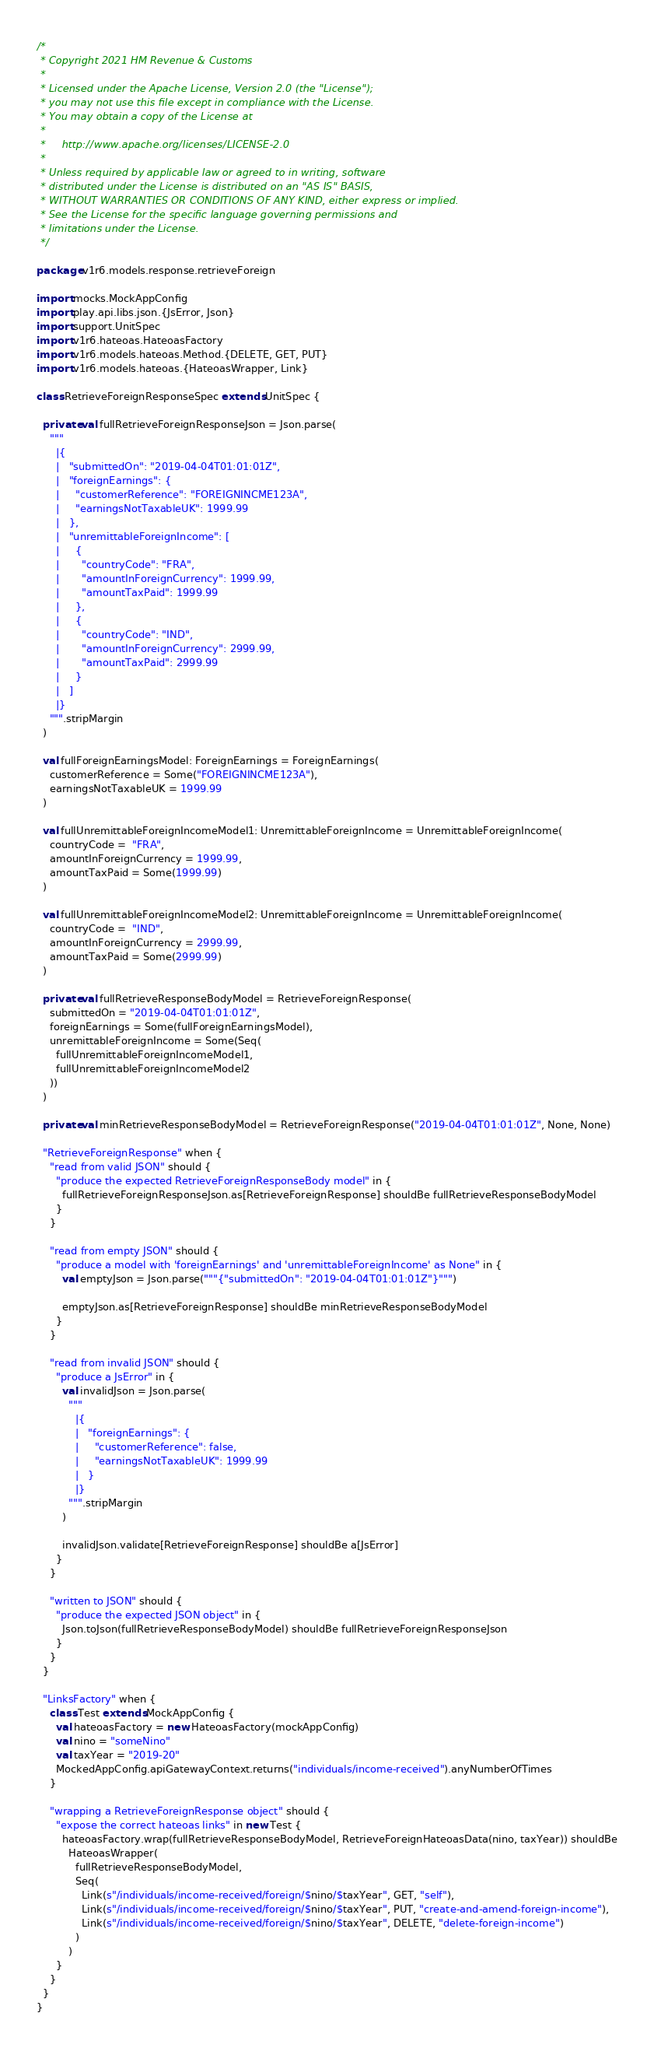<code> <loc_0><loc_0><loc_500><loc_500><_Scala_>/*
 * Copyright 2021 HM Revenue & Customs
 *
 * Licensed under the Apache License, Version 2.0 (the "License");
 * you may not use this file except in compliance with the License.
 * You may obtain a copy of the License at
 *
 *     http://www.apache.org/licenses/LICENSE-2.0
 *
 * Unless required by applicable law or agreed to in writing, software
 * distributed under the License is distributed on an "AS IS" BASIS,
 * WITHOUT WARRANTIES OR CONDITIONS OF ANY KIND, either express or implied.
 * See the License for the specific language governing permissions and
 * limitations under the License.
 */

package v1r6.models.response.retrieveForeign

import mocks.MockAppConfig
import play.api.libs.json.{JsError, Json}
import support.UnitSpec
import v1r6.hateoas.HateoasFactory
import v1r6.models.hateoas.Method.{DELETE, GET, PUT}
import v1r6.models.hateoas.{HateoasWrapper, Link}

class RetrieveForeignResponseSpec extends UnitSpec {

  private val fullRetrieveForeignResponseJson = Json.parse(
    """
      |{
      |   "submittedOn": "2019-04-04T01:01:01Z",
      |   "foreignEarnings": {
      |     "customerReference": "FOREIGNINCME123A",
      |     "earningsNotTaxableUK": 1999.99
      |   },
      |   "unremittableForeignIncome": [
      |     {
      |       "countryCode": "FRA",
      |       "amountInForeignCurrency": 1999.99,
      |       "amountTaxPaid": 1999.99
      |     },
      |     {
      |       "countryCode": "IND",
      |       "amountInForeignCurrency": 2999.99,
      |       "amountTaxPaid": 2999.99
      |     }
      |   ]
      |}
    """.stripMargin
  )

  val fullForeignEarningsModel: ForeignEarnings = ForeignEarnings(
    customerReference = Some("FOREIGNINCME123A"),
    earningsNotTaxableUK = 1999.99
  )

  val fullUnremittableForeignIncomeModel1: UnremittableForeignIncome = UnremittableForeignIncome(
    countryCode =  "FRA",
    amountInForeignCurrency = 1999.99,
    amountTaxPaid = Some(1999.99)
  )

  val fullUnremittableForeignIncomeModel2: UnremittableForeignIncome = UnremittableForeignIncome(
    countryCode =  "IND",
    amountInForeignCurrency = 2999.99,
    amountTaxPaid = Some(2999.99)
  )

  private val fullRetrieveResponseBodyModel = RetrieveForeignResponse(
    submittedOn = "2019-04-04T01:01:01Z",
    foreignEarnings = Some(fullForeignEarningsModel),
    unremittableForeignIncome = Some(Seq(
      fullUnremittableForeignIncomeModel1,
      fullUnremittableForeignIncomeModel2
    ))
  )

  private val minRetrieveResponseBodyModel = RetrieveForeignResponse("2019-04-04T01:01:01Z", None, None)

  "RetrieveForeignResponse" when {
    "read from valid JSON" should {
      "produce the expected RetrieveForeignResponseBody model" in {
        fullRetrieveForeignResponseJson.as[RetrieveForeignResponse] shouldBe fullRetrieveResponseBodyModel
      }
    }

    "read from empty JSON" should {
      "produce a model with 'foreignEarnings' and 'unremittableForeignIncome' as None" in {
        val emptyJson = Json.parse("""{"submittedOn": "2019-04-04T01:01:01Z"}""")

        emptyJson.as[RetrieveForeignResponse] shouldBe minRetrieveResponseBodyModel
      }
    }

    "read from invalid JSON" should {
      "produce a JsError" in {
        val invalidJson = Json.parse(
          """
            |{
            |   "foreignEarnings": {
            |     "customerReference": false,
            |     "earningsNotTaxableUK": 1999.99
            |   }
            |}
          """.stripMargin
        )

        invalidJson.validate[RetrieveForeignResponse] shouldBe a[JsError]
      }
    }

    "written to JSON" should {
      "produce the expected JSON object" in {
        Json.toJson(fullRetrieveResponseBodyModel) shouldBe fullRetrieveForeignResponseJson
      }
    }
  }

  "LinksFactory" when {
    class Test extends MockAppConfig {
      val hateoasFactory = new HateoasFactory(mockAppConfig)
      val nino = "someNino"
      val taxYear = "2019-20"
      MockedAppConfig.apiGatewayContext.returns("individuals/income-received").anyNumberOfTimes
    }

    "wrapping a RetrieveForeignResponse object" should {
      "expose the correct hateoas links" in new Test {
        hateoasFactory.wrap(fullRetrieveResponseBodyModel, RetrieveForeignHateoasData(nino, taxYear)) shouldBe
          HateoasWrapper(
            fullRetrieveResponseBodyModel,
            Seq(
              Link(s"/individuals/income-received/foreign/$nino/$taxYear", GET, "self"),
              Link(s"/individuals/income-received/foreign/$nino/$taxYear", PUT, "create-and-amend-foreign-income"),
              Link(s"/individuals/income-received/foreign/$nino/$taxYear", DELETE, "delete-foreign-income")
            )
          )
      }
    }
  }
}
</code> 